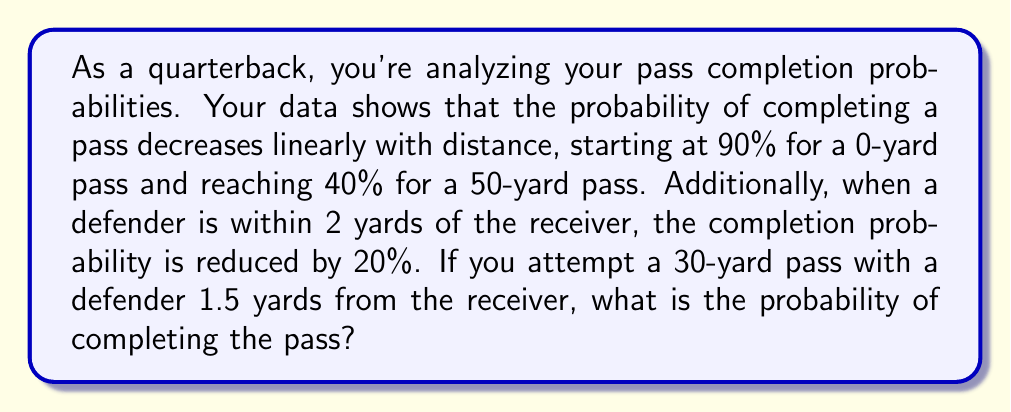Solve this math problem. Let's approach this problem step-by-step:

1) First, we need to find the linear function that describes the probability of completion based on distance. We can use the point-slope form of a line:

   $$(y - y_1) = m(x - x_1)$$

   Where $m$ is the slope, $(x_1, y_1)$ is a known point, $x$ is the input (distance), and $y$ is the output (probability).

2) We know two points: (0, 0.90) and (50, 0.40). Let's calculate the slope:

   $$m = \frac{0.40 - 0.90}{50 - 0} = -0.01$$

3) Now we can form our equation using the point (0, 0.90):

   $$(y - 0.90) = -0.01(x - 0)$$
   $$y = -0.01x + 0.90$$

4) For a 30-yard pass, we plug in x = 30:

   $$y = -0.01(30) + 0.90 = 0.60$$

5) So, without defensive coverage, the probability would be 60%.

6) However, we need to account for the defender. Since the defender is within 2 yards (1.5 yards), we reduce the probability by 20%:

   $$0.60 * (1 - 0.20) = 0.60 * 0.80 = 0.48$$

Therefore, the probability of completing the pass is 48%.
Answer: 48% 